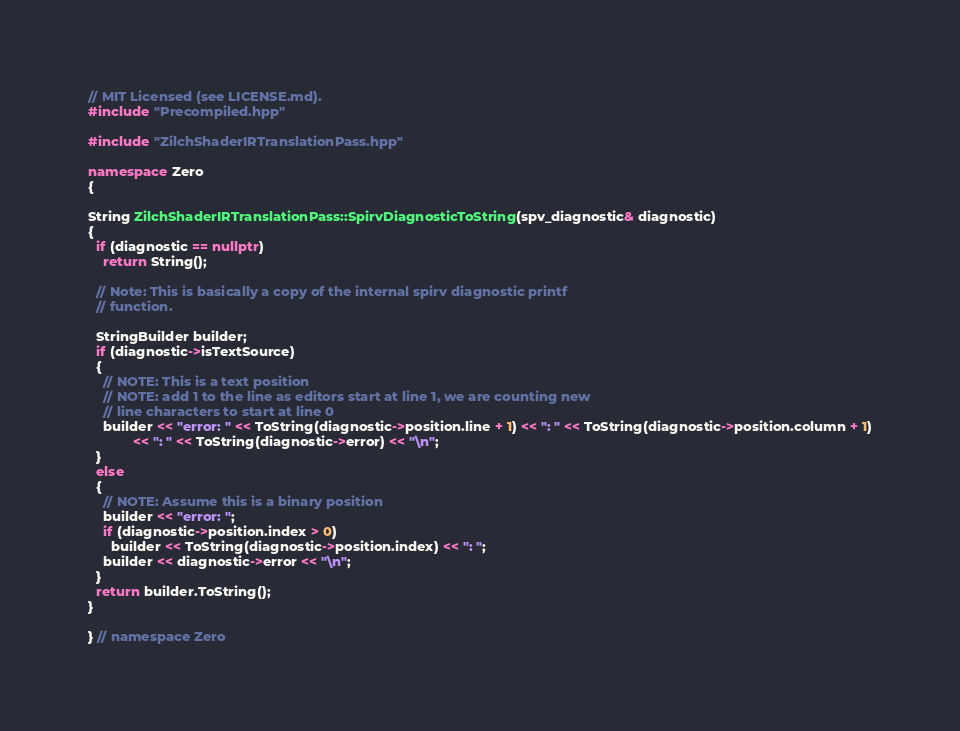Convert code to text. <code><loc_0><loc_0><loc_500><loc_500><_C++_>// MIT Licensed (see LICENSE.md).
#include "Precompiled.hpp"

#include "ZilchShaderIRTranslationPass.hpp"

namespace Zero
{

String ZilchShaderIRTranslationPass::SpirvDiagnosticToString(spv_diagnostic& diagnostic)
{
  if (diagnostic == nullptr)
    return String();

  // Note: This is basically a copy of the internal spirv diagnostic printf
  // function.

  StringBuilder builder;
  if (diagnostic->isTextSource)
  {
    // NOTE: This is a text position
    // NOTE: add 1 to the line as editors start at line 1, we are counting new
    // line characters to start at line 0
    builder << "error: " << ToString(diagnostic->position.line + 1) << ": " << ToString(diagnostic->position.column + 1)
            << ": " << ToString(diagnostic->error) << "\n";
  }
  else
  {
    // NOTE: Assume this is a binary position
    builder << "error: ";
    if (diagnostic->position.index > 0)
      builder << ToString(diagnostic->position.index) << ": ";
    builder << diagnostic->error << "\n";
  }
  return builder.ToString();
}

} // namespace Zero
</code> 